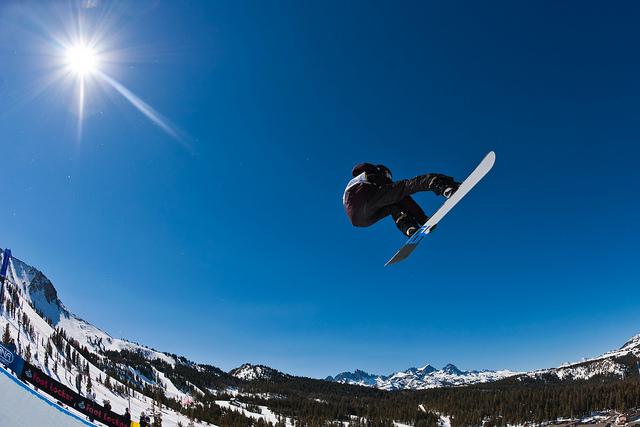Is the ramp behind or in front of the skateboarder?
Answer briefly. Behind. Does the person have one or two feet on the board?
Concise answer only. 2. Is he going uphill or downhill?
Concise answer only. Downhill. Is he on a skateboard?
Keep it brief. No. What does the bottom of the snowboard say?
Quick response, please. Can't tell. How many hands is the snowboarder using to grab his snowboard?
Give a very brief answer. 1. What color is the person's gloves?
Be succinct. Black. Which hand is the man holding the snowboard with?
Keep it brief. Right. Is the person a professional?
Be succinct. Yes. 